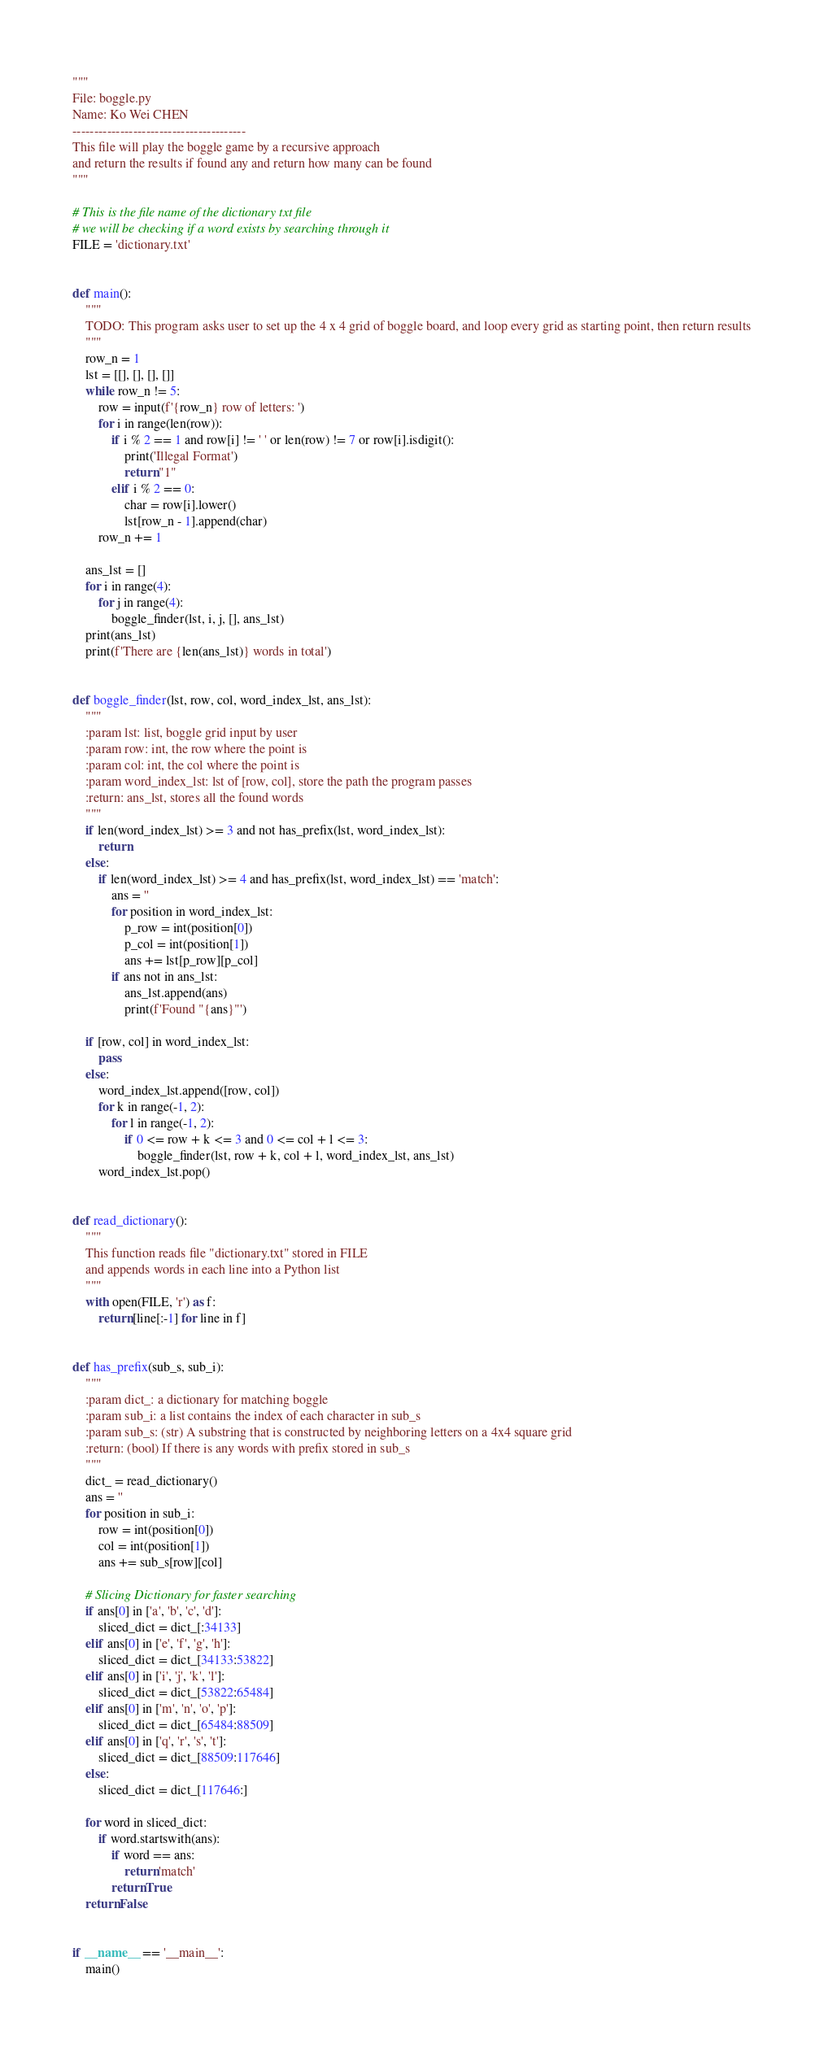<code> <loc_0><loc_0><loc_500><loc_500><_Python_>"""
File: boggle.py
Name: Ko Wei CHEN
----------------------------------------
This file will play the boggle game by a recursive approach
and return the results if found any and return how many can be found
"""

# This is the file name of the dictionary txt file
# we will be checking if a word exists by searching through it
FILE = 'dictionary.txt'


def main():
	"""
	TODO: This program asks user to set up the 4 x 4 grid of boggle board, and loop every grid as starting point, then return results
	"""
	row_n = 1
	lst = [[], [], [], []]
	while row_n != 5:
		row = input(f'{row_n} row of letters: ')
		for i in range(len(row)):
			if i % 2 == 1 and row[i] != ' ' or len(row) != 7 or row[i].isdigit():
				print('Illegal Format')
				return "1"
			elif i % 2 == 0:
				char = row[i].lower()
				lst[row_n - 1].append(char)
		row_n += 1

	ans_lst = []
	for i in range(4):
		for j in range(4):
			boggle_finder(lst, i, j, [], ans_lst)
	print(ans_lst)
	print(f'There are {len(ans_lst)} words in total')


def boggle_finder(lst, row, col, word_index_lst, ans_lst):
	"""
	:param lst: list, boggle grid input by user
	:param row: int, the row where the point is
	:param col: int, the col where the point is
	:param word_index_lst: lst of [row, col], store the path the program passes
	:return: ans_lst, stores all the found words
	"""
	if len(word_index_lst) >= 3 and not has_prefix(lst, word_index_lst):
		return
	else:
		if len(word_index_lst) >= 4 and has_prefix(lst, word_index_lst) == 'match':
			ans = ''
			for position in word_index_lst:
				p_row = int(position[0])
				p_col = int(position[1])
				ans += lst[p_row][p_col]
			if ans not in ans_lst:
				ans_lst.append(ans)
				print(f'Found "{ans}"')

	if [row, col] in word_index_lst:
		pass
	else:
		word_index_lst.append([row, col])
		for k in range(-1, 2):
			for l in range(-1, 2):
				if 0 <= row + k <= 3 and 0 <= col + l <= 3:
					boggle_finder(lst, row + k, col + l, word_index_lst, ans_lst)
		word_index_lst.pop()


def read_dictionary():
	"""
	This function reads file "dictionary.txt" stored in FILE
	and appends words in each line into a Python list
	"""
	with open(FILE, 'r') as f:
		return [line[:-1] for line in f]


def has_prefix(sub_s, sub_i):
	"""
	:param dict_: a dictionary for matching boggle
	:param sub_i: a list contains the index of each character in sub_s
	:param sub_s: (str) A substring that is constructed by neighboring letters on a 4x4 square grid
	:return: (bool) If there is any words with prefix stored in sub_s
	"""
	dict_ = read_dictionary()
	ans = ''
	for position in sub_i:
		row = int(position[0])
		col = int(position[1])
		ans += sub_s[row][col]

	# Slicing Dictionary for faster searching
	if ans[0] in ['a', 'b', 'c', 'd']:
		sliced_dict = dict_[:34133]
	elif ans[0] in ['e', 'f', 'g', 'h']:
		sliced_dict = dict_[34133:53822]
	elif ans[0] in ['i', 'j', 'k', 'l']:
		sliced_dict = dict_[53822:65484]
	elif ans[0] in ['m', 'n', 'o', 'p']:
		sliced_dict = dict_[65484:88509]
	elif ans[0] in ['q', 'r', 's', 't']:
		sliced_dict = dict_[88509:117646]
	else:
		sliced_dict = dict_[117646:]

	for word in sliced_dict:
		if word.startswith(ans):
			if word == ans:
				return 'match'
			return True
	return False


if __name__ == '__main__':
	main()
</code> 